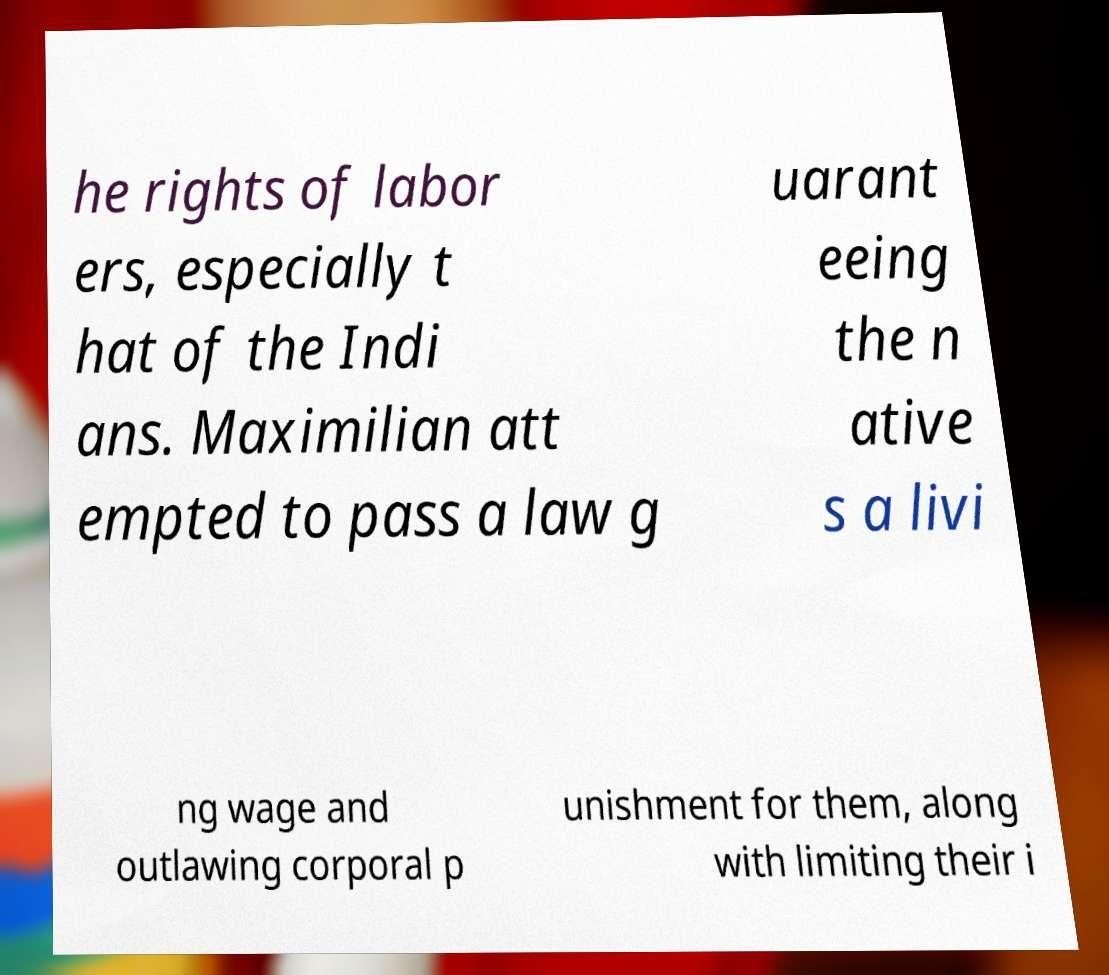There's text embedded in this image that I need extracted. Can you transcribe it verbatim? he rights of labor ers, especially t hat of the Indi ans. Maximilian att empted to pass a law g uarant eeing the n ative s a livi ng wage and outlawing corporal p unishment for them, along with limiting their i 